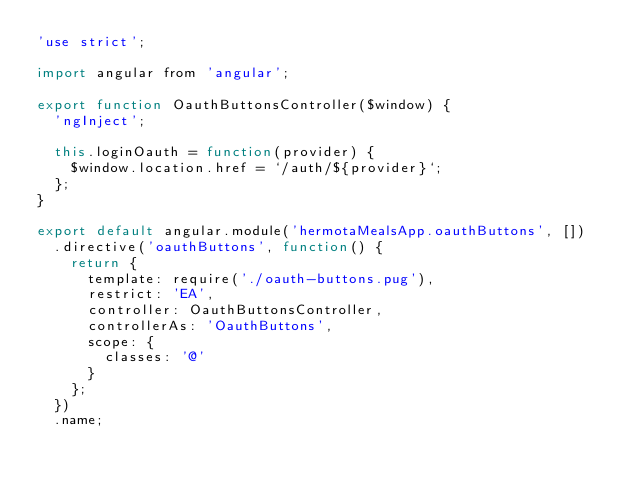<code> <loc_0><loc_0><loc_500><loc_500><_JavaScript_>'use strict';

import angular from 'angular';

export function OauthButtonsController($window) {
  'ngInject';

  this.loginOauth = function(provider) {
    $window.location.href = `/auth/${provider}`;
  };
}

export default angular.module('hermotaMealsApp.oauthButtons', [])
  .directive('oauthButtons', function() {
    return {
      template: require('./oauth-buttons.pug'),
      restrict: 'EA',
      controller: OauthButtonsController,
      controllerAs: 'OauthButtons',
      scope: {
        classes: '@'
      }
    };
  })
  .name;
</code> 